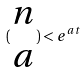Convert formula to latex. <formula><loc_0><loc_0><loc_500><loc_500>( \begin{matrix} n \\ a \end{matrix} ) < e ^ { a t }</formula> 